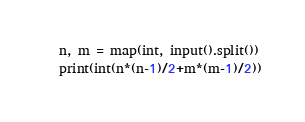<code> <loc_0><loc_0><loc_500><loc_500><_Python_>n, m = map(int, input().split())
print(int(n*(n-1)/2+m*(m-1)/2))</code> 